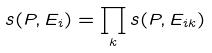<formula> <loc_0><loc_0><loc_500><loc_500>s ( P , E _ { i } ) = \prod _ { k } s ( P , E _ { i k } )</formula> 